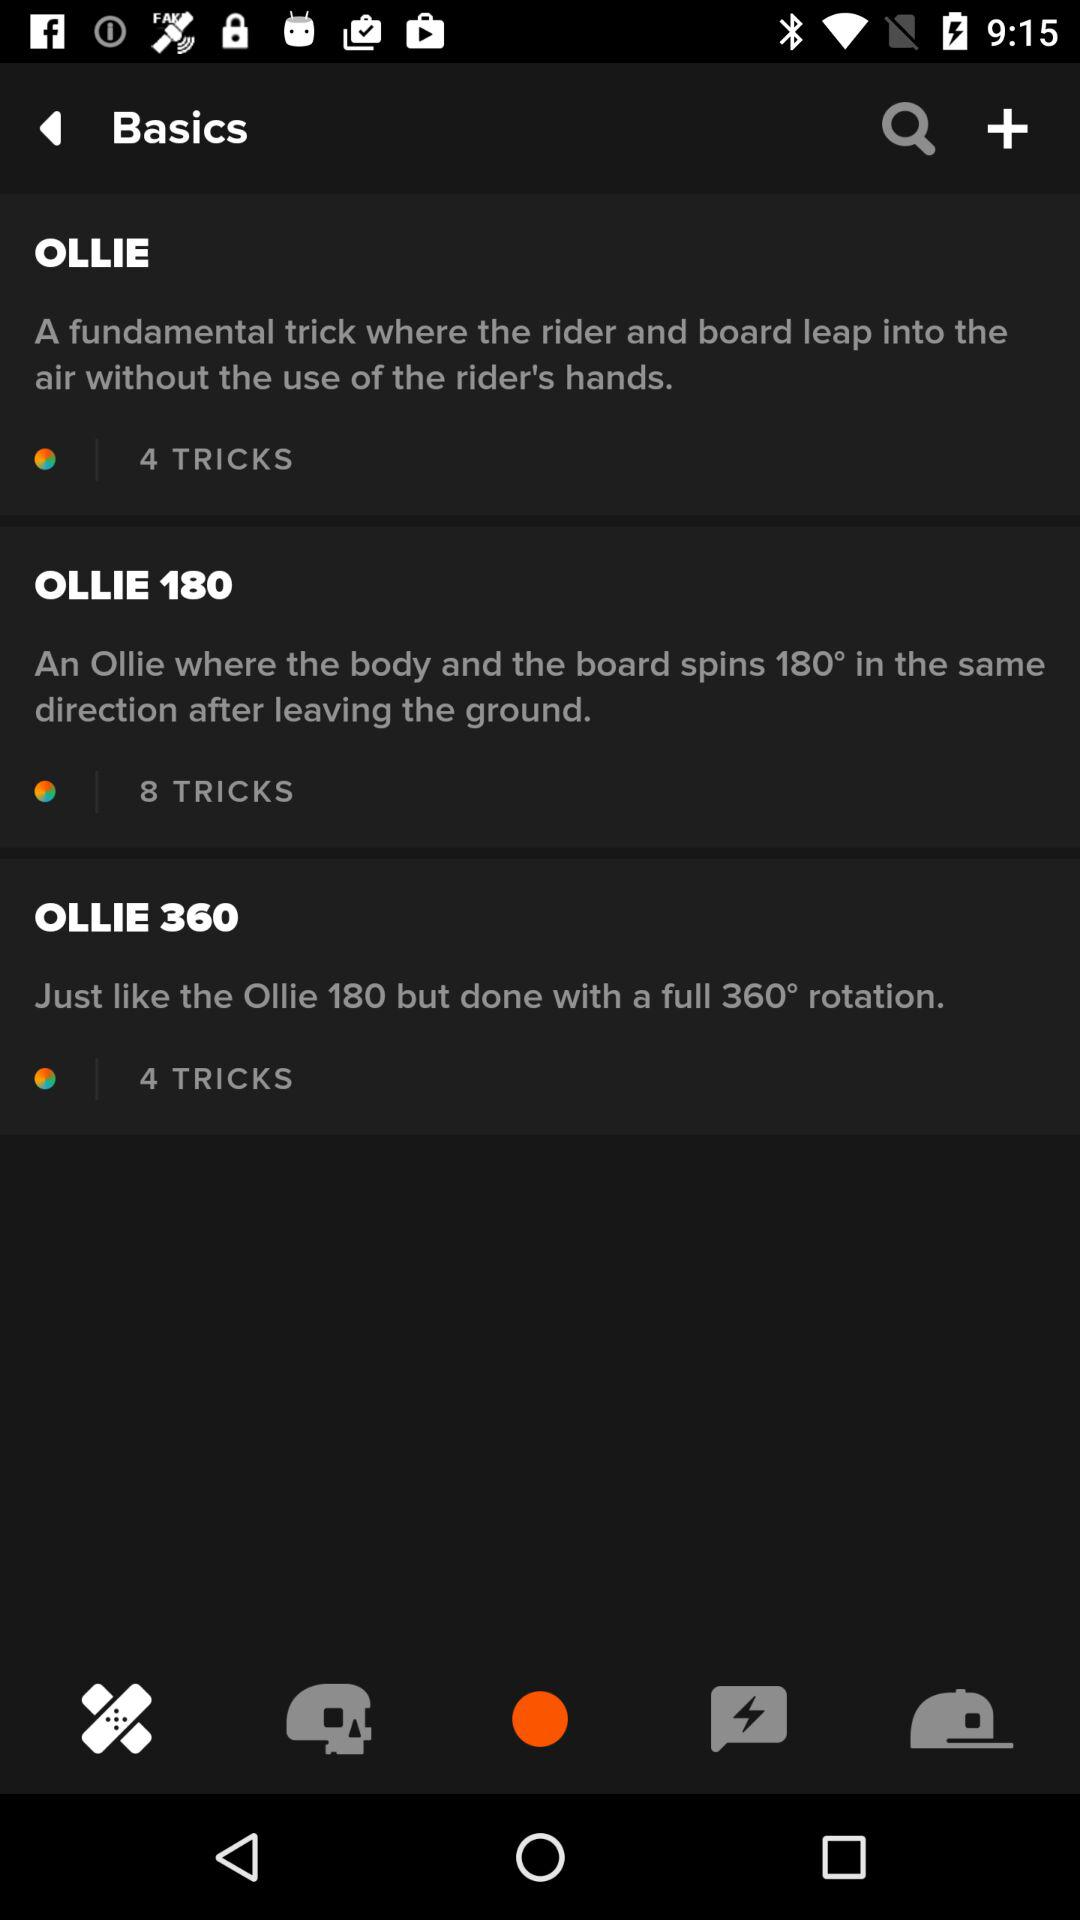How many more tricks are there for the Ollie 180 than the Ollie 360?
Answer the question using a single word or phrase. 4 